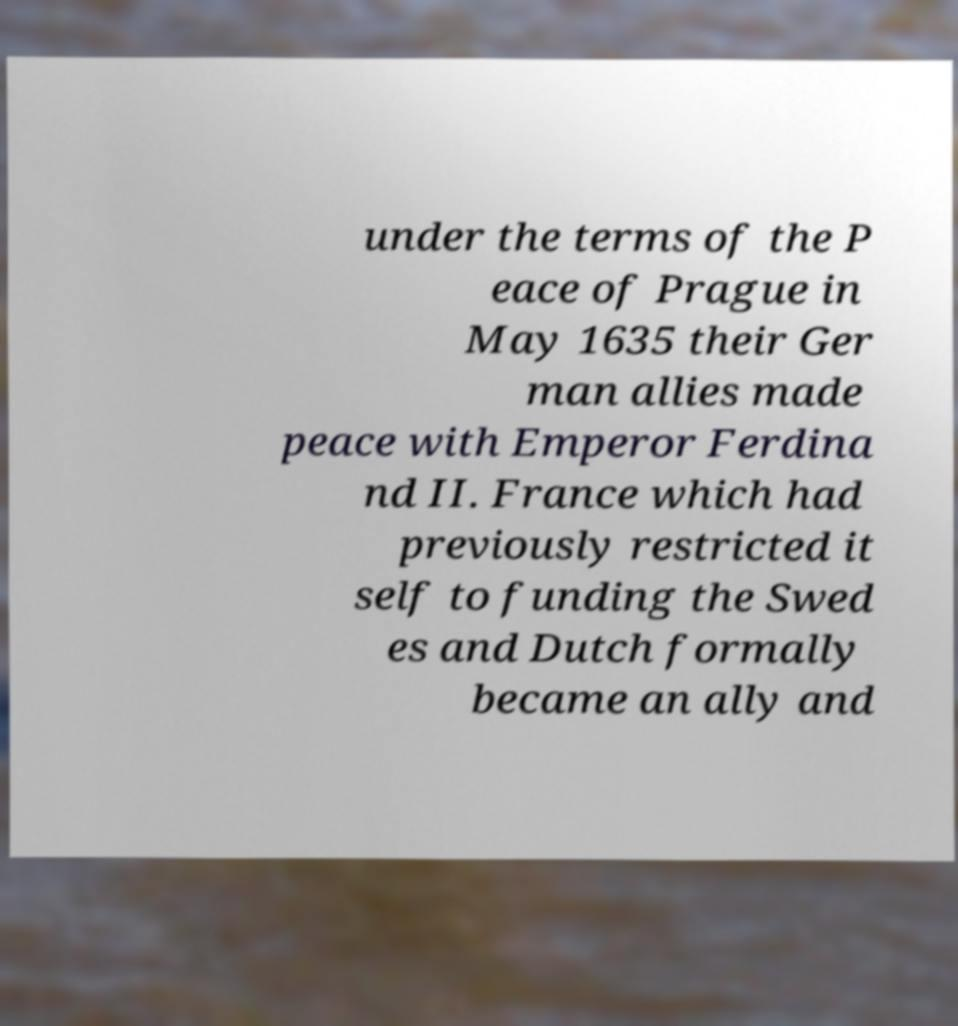Can you read and provide the text displayed in the image?This photo seems to have some interesting text. Can you extract and type it out for me? under the terms of the P eace of Prague in May 1635 their Ger man allies made peace with Emperor Ferdina nd II. France which had previously restricted it self to funding the Swed es and Dutch formally became an ally and 